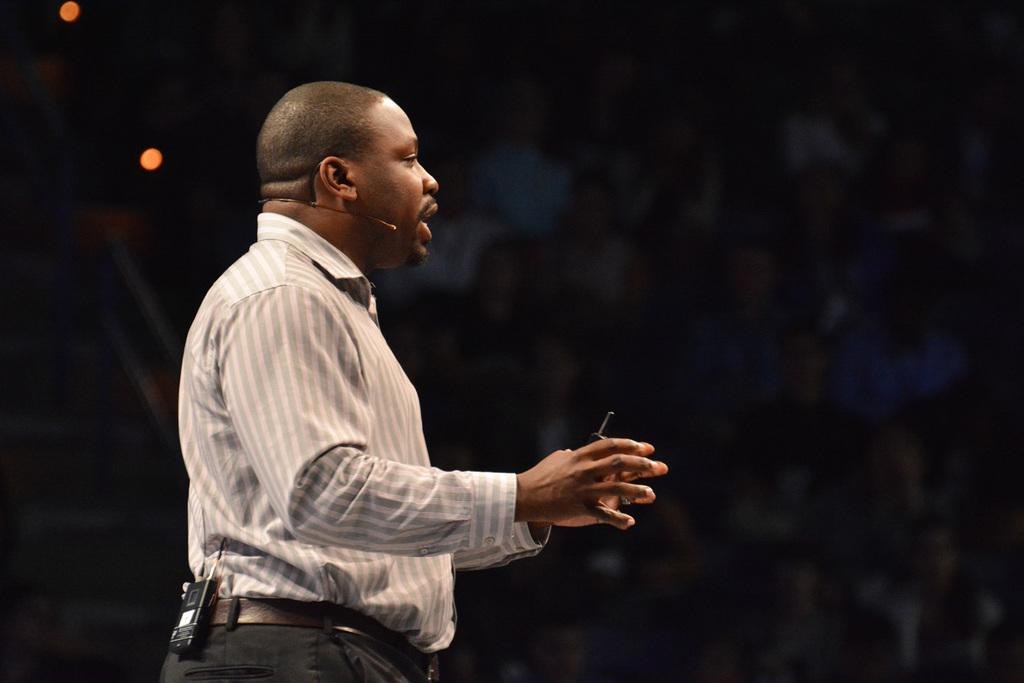What is the person in the image doing? The person is standing in the image and holding a microphone. What else is the person holding in the image? The person is holding an object in his hand. What can be seen in the background of the image? The backdrop of the image is dark. What type of nerve can be seen in the person's hand in the image? There is no nerve visible in the person's hand in the image. What type of quilt is draped over the person's shoulders in the image? There is no quilt present in the image. 